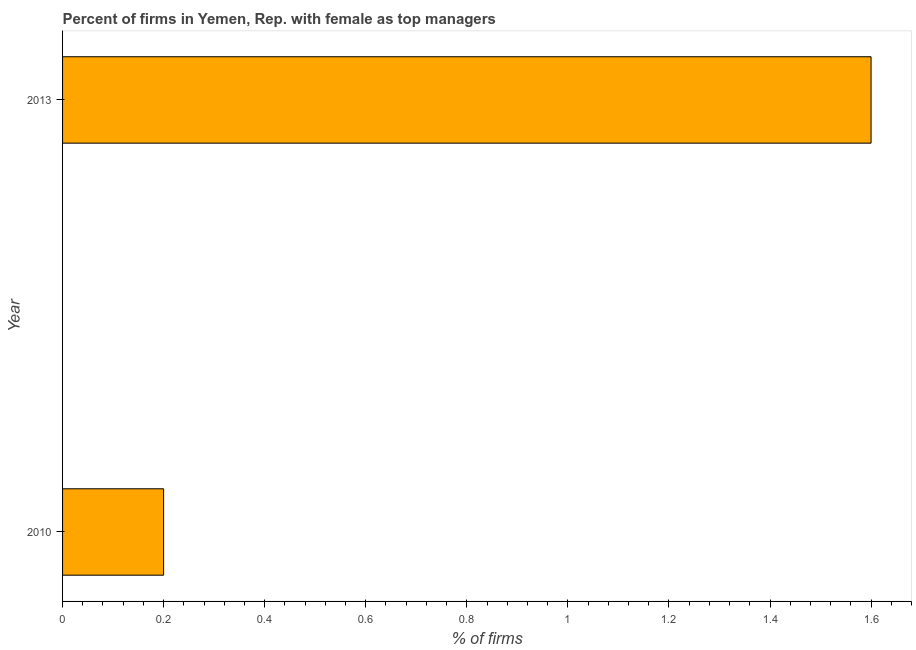Does the graph contain grids?
Your response must be concise. No. What is the title of the graph?
Provide a succinct answer. Percent of firms in Yemen, Rep. with female as top managers. What is the label or title of the X-axis?
Your response must be concise. % of firms. In which year was the percentage of firms with female as top manager minimum?
Keep it short and to the point. 2010. What is the sum of the percentage of firms with female as top manager?
Ensure brevity in your answer.  1.8. In how many years, is the percentage of firms with female as top manager greater than the average percentage of firms with female as top manager taken over all years?
Keep it short and to the point. 1. Are all the bars in the graph horizontal?
Make the answer very short. Yes. What is the difference between two consecutive major ticks on the X-axis?
Your answer should be very brief. 0.2. Are the values on the major ticks of X-axis written in scientific E-notation?
Your answer should be very brief. No. What is the % of firms in 2010?
Offer a terse response. 0.2. What is the ratio of the % of firms in 2010 to that in 2013?
Your answer should be very brief. 0.12. 